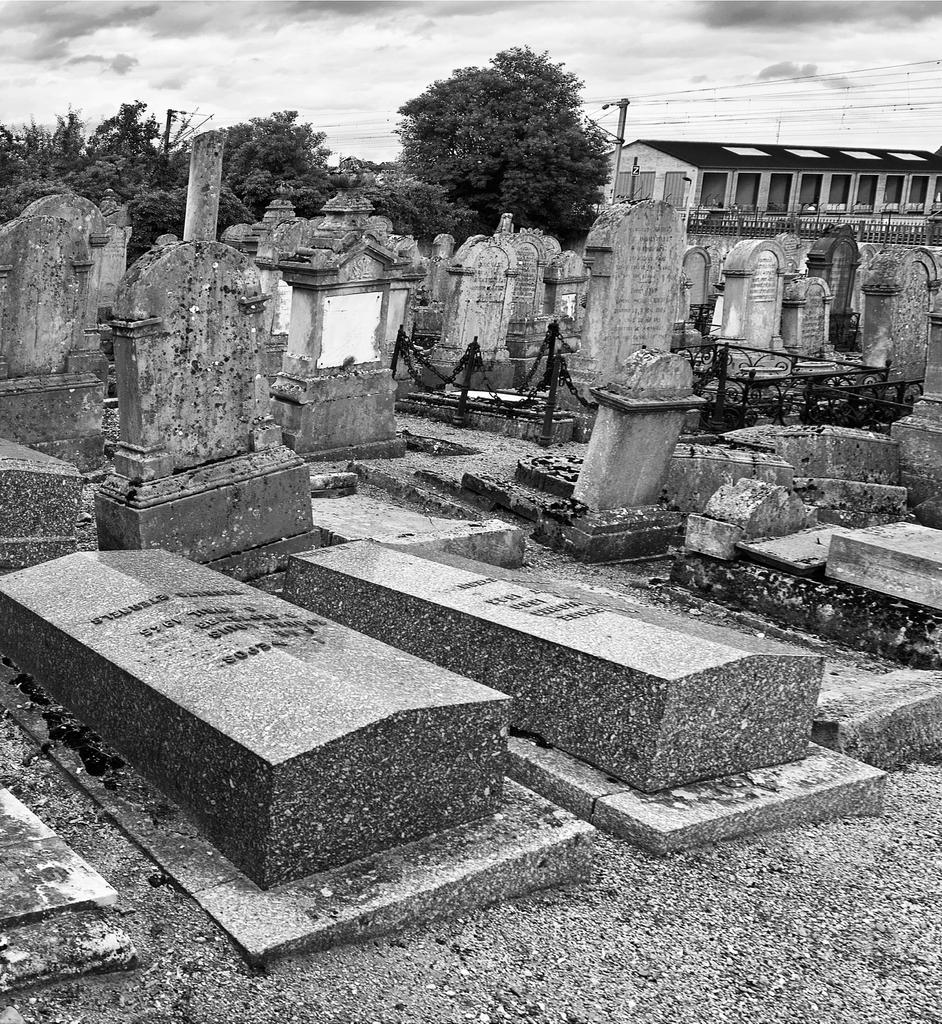What is the color scheme of the image? The image is black and white. What type of location is depicted in the image? The location depicted in the image is a graveyard. What can be seen in the background of the image? There are trees and a building in the background of the image. What is visible at the top of the image? The sky is visible at the top of the image. Can you see a hen smashing into the building in the image? No, there is no hen or any indication of smashing in the image. Is there a sink visible in the image? No, there is no sink present in the image. 